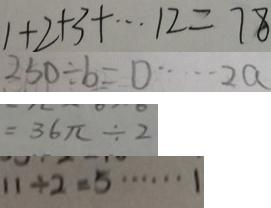Convert formula to latex. <formula><loc_0><loc_0><loc_500><loc_500>1 + 2 + 3 + \cdots 1 3 2 = 7 8 
 2 5 0 \div b = \square \cdots 2 a 
 = 3 6 \pi \div 2 
 1 1 \div 2 = 5 \cdots 1</formula> 